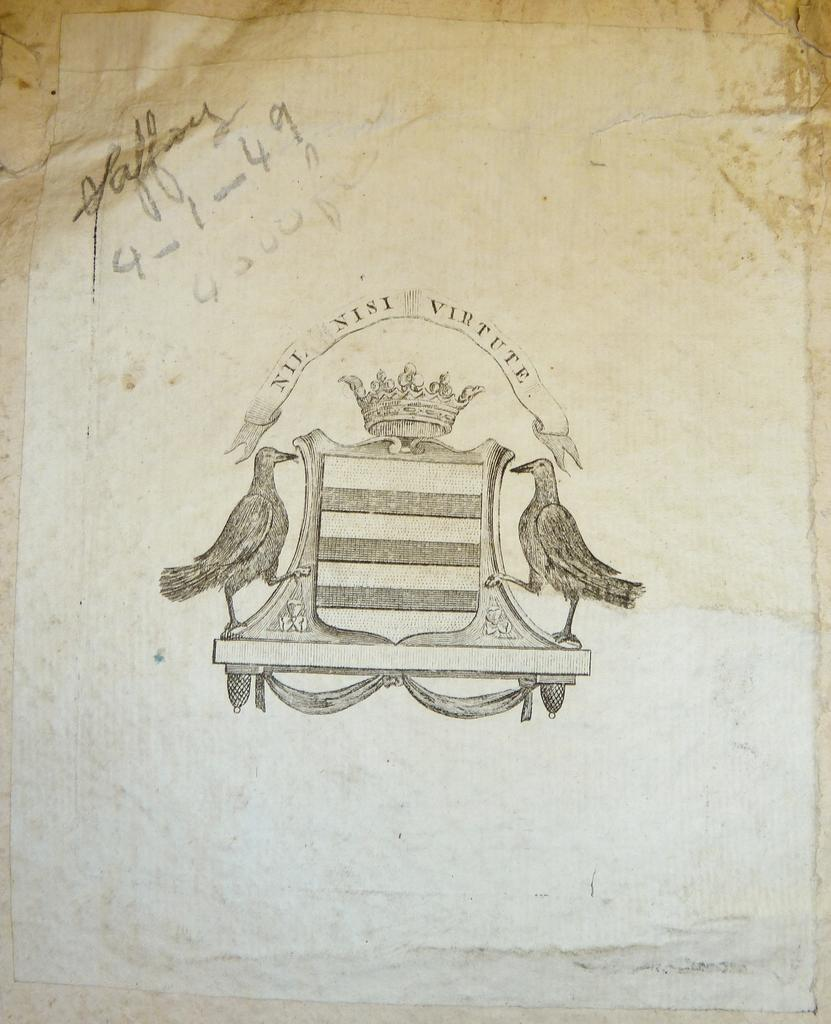What is the main subject of the image? The main subject of the image is a white color paper. What is depicted on the paper? There is a pencil art on the paper. Can you tell me how many requests are made on the shirt in the image? There is no shirt present in the image, and therefore no requests can be observed. What type of frog can be seen interacting with the pencil art on the paper? There is no frog present in the image; it only features a white color paper with pencil art on it. 